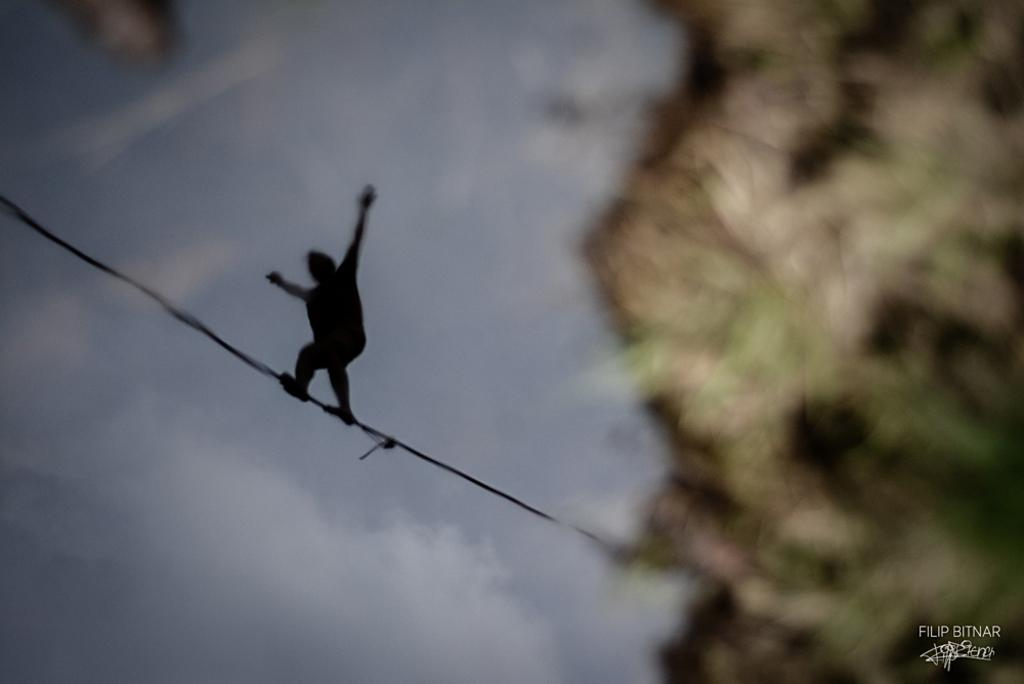What is the main subject of the image? There is a man in the image. What is the man doing in the image? The man is standing on a rope. What can be seen in the background of the image? The sky is visible in the image. What type of winter clothing is the fireman wearing in the image? There is no fireman or winter clothing present in the image; it features a man standing on a rope with the sky visible in the background. 